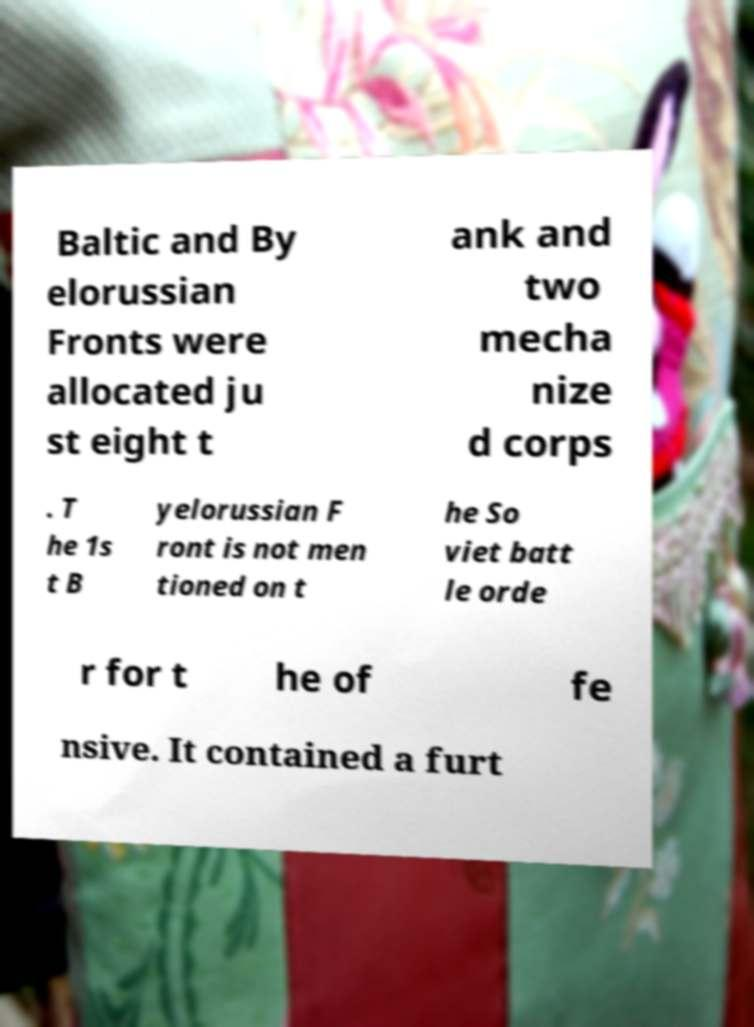For documentation purposes, I need the text within this image transcribed. Could you provide that? Baltic and By elorussian Fronts were allocated ju st eight t ank and two mecha nize d corps . T he 1s t B yelorussian F ront is not men tioned on t he So viet batt le orde r for t he of fe nsive. It contained a furt 